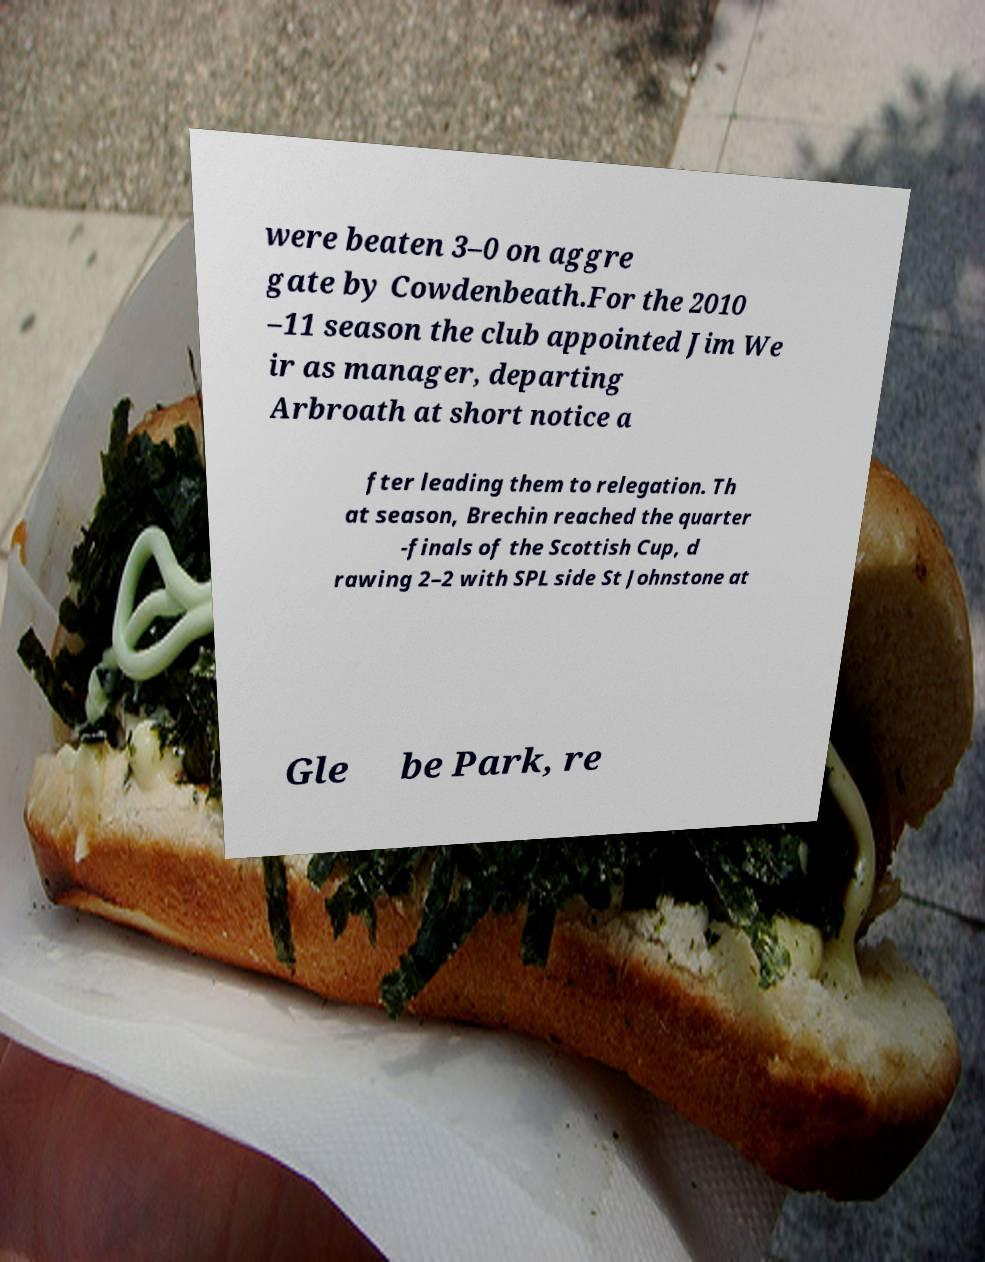What messages or text are displayed in this image? I need them in a readable, typed format. were beaten 3–0 on aggre gate by Cowdenbeath.For the 2010 –11 season the club appointed Jim We ir as manager, departing Arbroath at short notice a fter leading them to relegation. Th at season, Brechin reached the quarter -finals of the Scottish Cup, d rawing 2–2 with SPL side St Johnstone at Gle be Park, re 